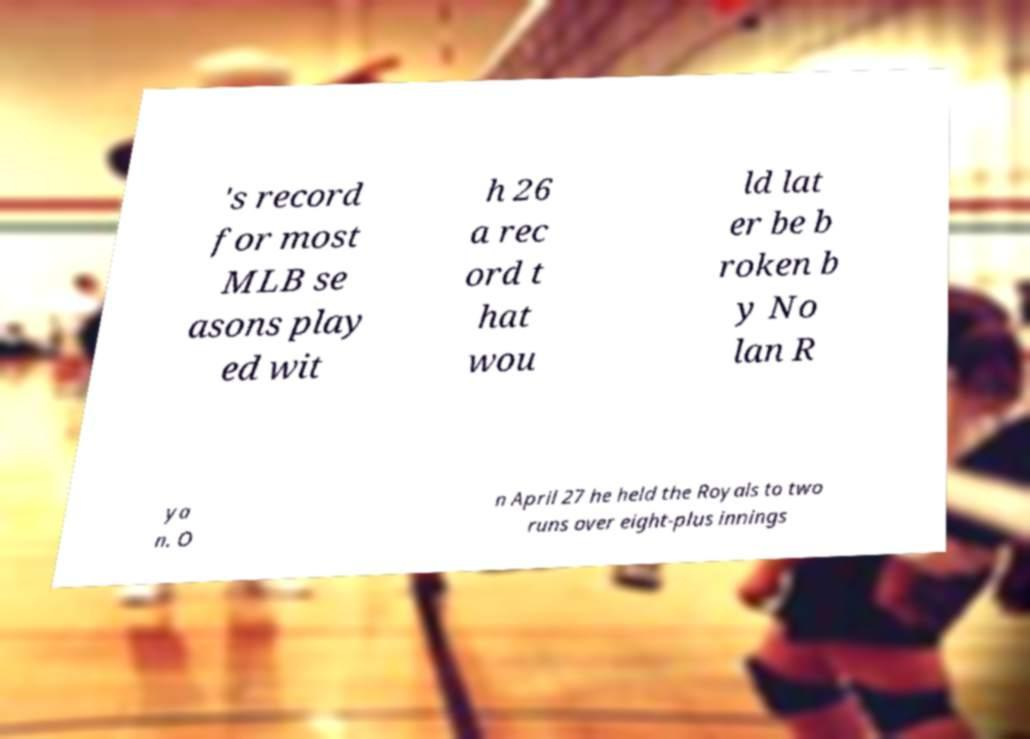Can you read and provide the text displayed in the image?This photo seems to have some interesting text. Can you extract and type it out for me? 's record for most MLB se asons play ed wit h 26 a rec ord t hat wou ld lat er be b roken b y No lan R ya n. O n April 27 he held the Royals to two runs over eight-plus innings 